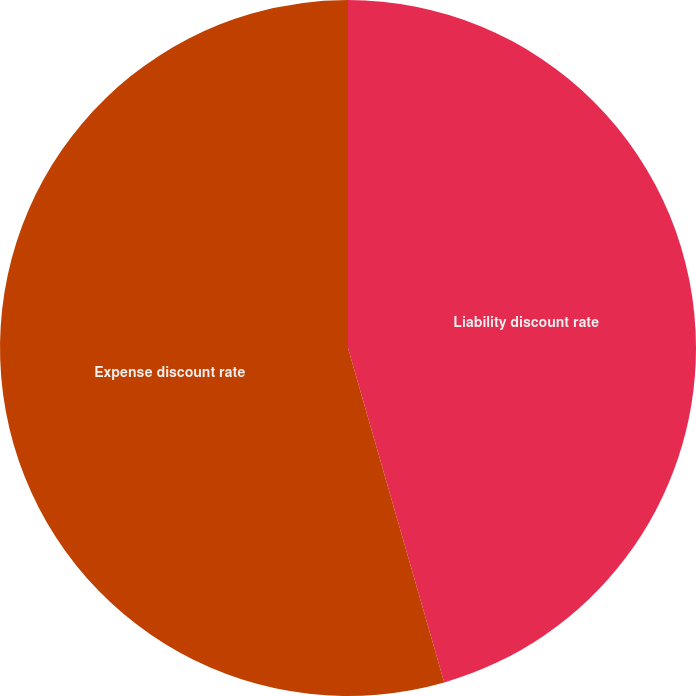Convert chart to OTSL. <chart><loc_0><loc_0><loc_500><loc_500><pie_chart><fcel>Liability discount rate<fcel>Expense discount rate<nl><fcel>45.54%<fcel>54.46%<nl></chart> 